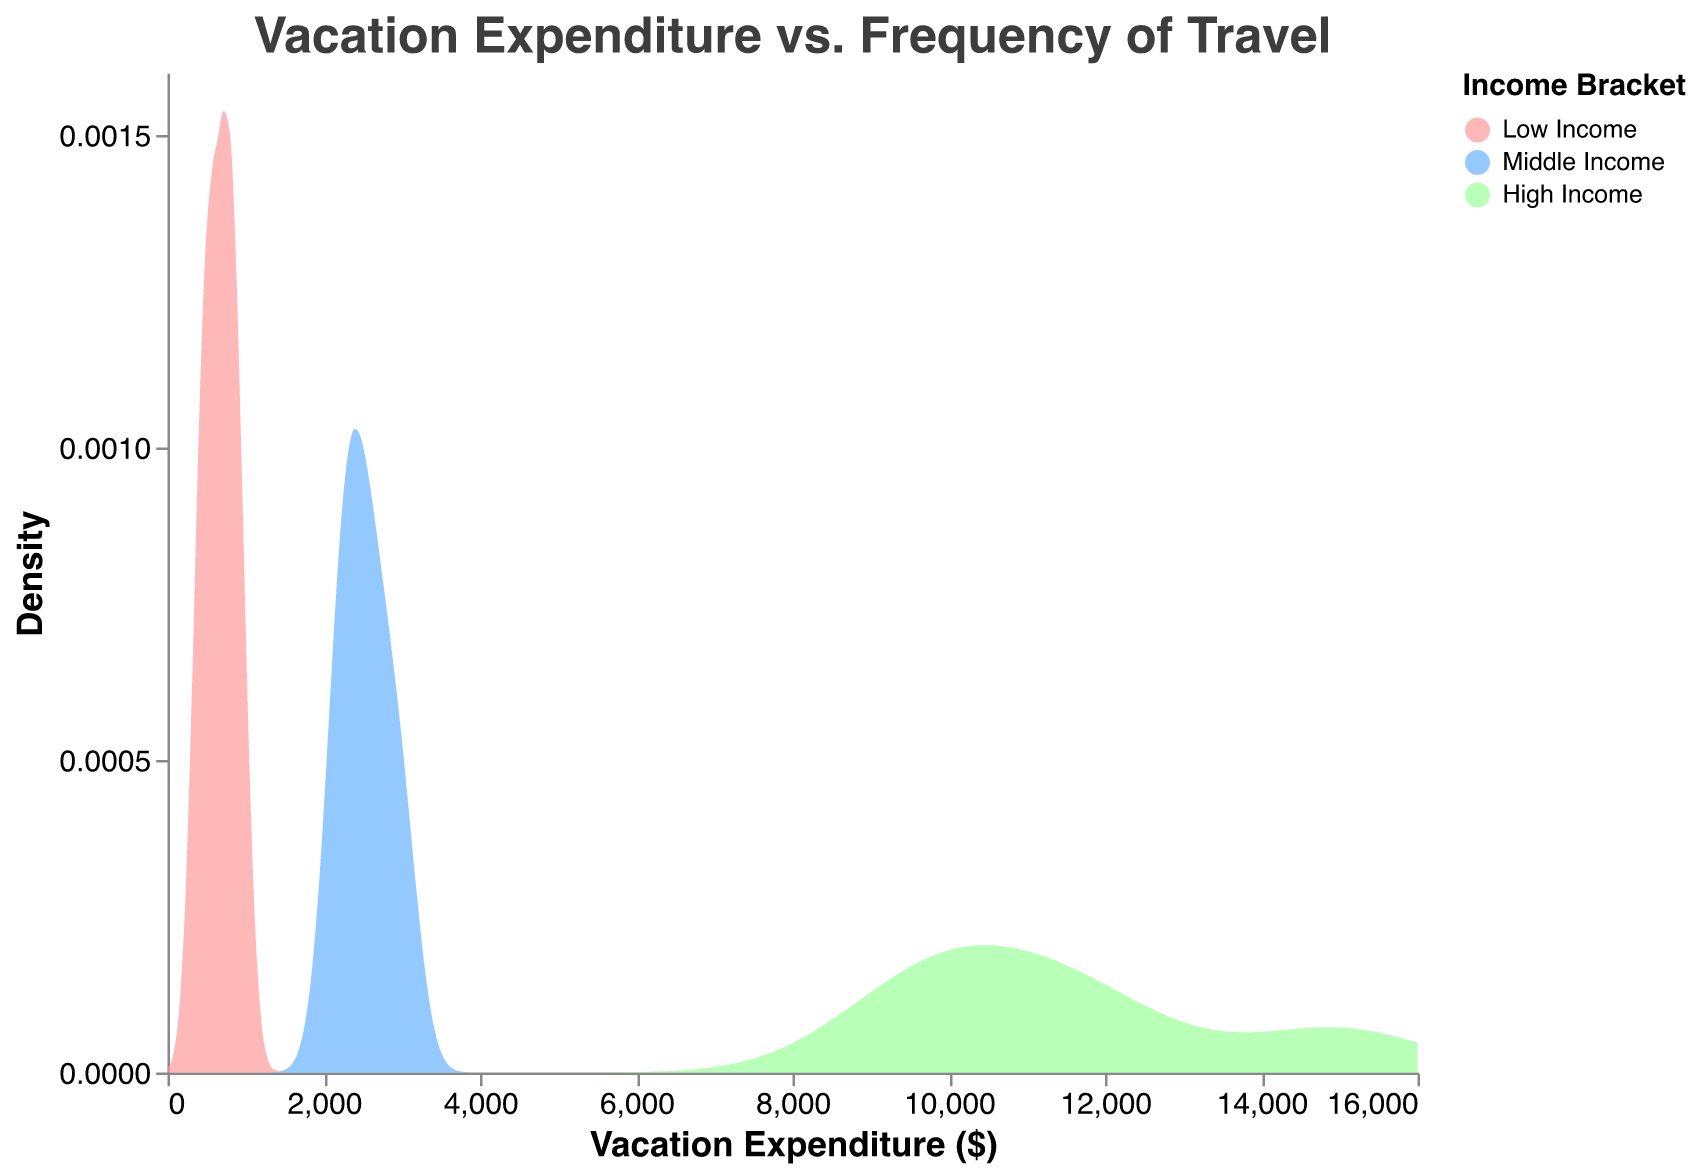What is the title of the plot? The title of the figure can be found at the top. In this case, it reads "Vacation Expenditure vs. Frequency of Travel".
Answer: Vacation Expenditure vs. Frequency of Travel What are the three income brackets represented in the plot? The color legend shows three different income brackets: Low Income, Middle Income, and High Income.
Answer: Low Income, Middle Income, High Income Which income bracket has the highest density of low vacation expenditure? By looking at the left end of the x-axis, the density for the Low Income bracket is visibly higher than Middle Income and High Income.
Answer: Low Income Where is the peak density for the High Income bracket located? The peak density for the High Income bracket occurs around $12,000 vacation expenditure, as indicated by the highest point on the green curve.
Answer: $12,000 How do the densities of the vacation expenditure compare between Low Income and High Income at around $1,000? The density for Low Income is much higher than for High Income at around $1,000, as observed from the shape of the curves.
Answer: Low Income is higher Which income bracket shows the widest spread of vacation expenditure? The High Income bracket has the widest spread ranging up to $15,000, compared to the other brackets.
Answer: High Income Does the Middle Income bracket have any data points with vacation expenditure above $3,000? No, the Middle Income bracket curve does not extend beyond the $3,000 mark, indicating no data points above that value.
Answer: No Is the density at a $3,000 vacation expenditure higher for Middle Income or High Income? The density for the High Income bracket is higher at the $3,000 mark when compared to the Middle Income bracket, as seen in the curves.
Answer: High Income What can you infer about the trend in vacation expenditure as income increases? As income increases, the density curves shift towards higher vacation expenditure values indicating higher spending. Low Income focuses on lower expenditures, Middle Income has moderate expenditures, and High Income has a wide spread of higher expenditures.
Answer: Higher income leads to higher vacation expenditure At which point does the Middle Income bracket's density peak? The Middle Income bracket shows its peak density around a $2,500 vacation expenditure, as indicated by the highest point on the blue curve.
Answer: $2,500 